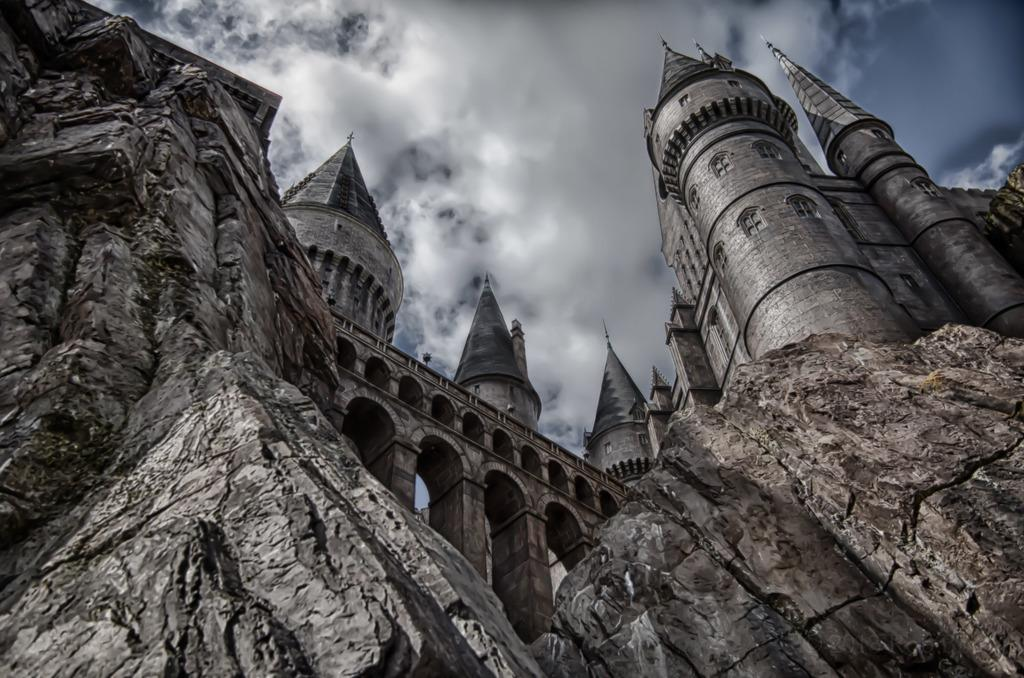What type of structures are located on the mountain in the image? There are buildings on a mountain in the image. What features do the buildings have? The buildings have roofs and windows. What can be seen in the sky in the background of the image? There are clouds in the sky in the background. Can you tell me how many geese are swimming in the river in the image? There is no river or geese present in the image; it features buildings on a mountain with clouds in the sky. 